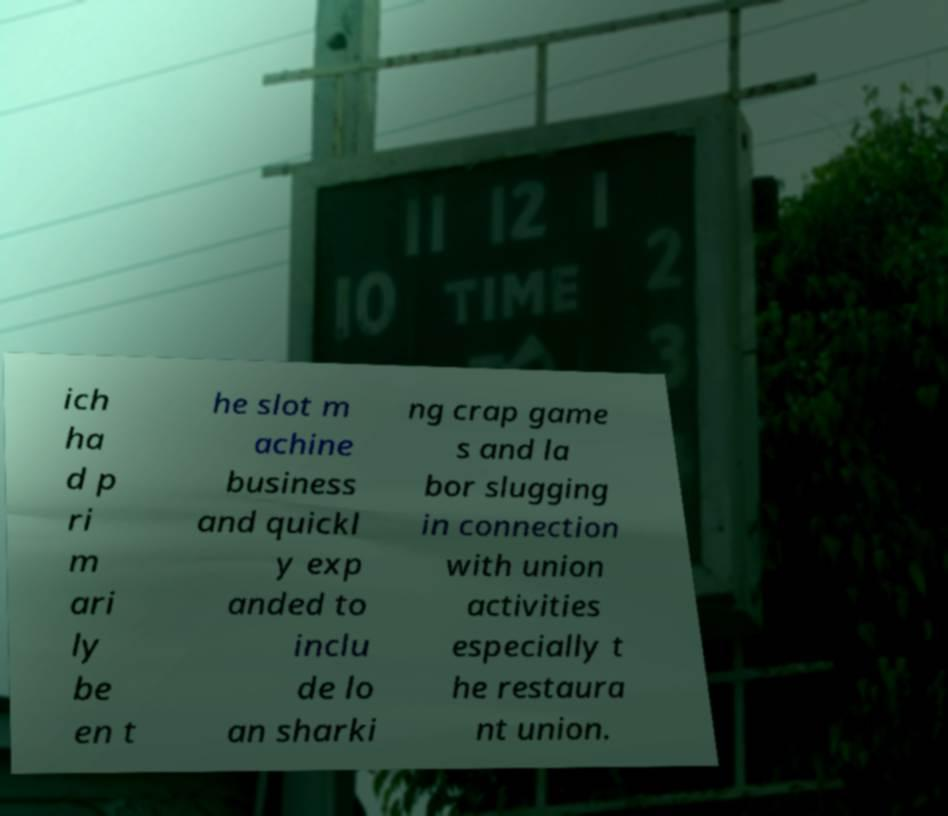Could you extract and type out the text from this image? ich ha d p ri m ari ly be en t he slot m achine business and quickl y exp anded to inclu de lo an sharki ng crap game s and la bor slugging in connection with union activities especially t he restaura nt union. 